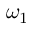Convert formula to latex. <formula><loc_0><loc_0><loc_500><loc_500>\omega _ { 1 }</formula> 